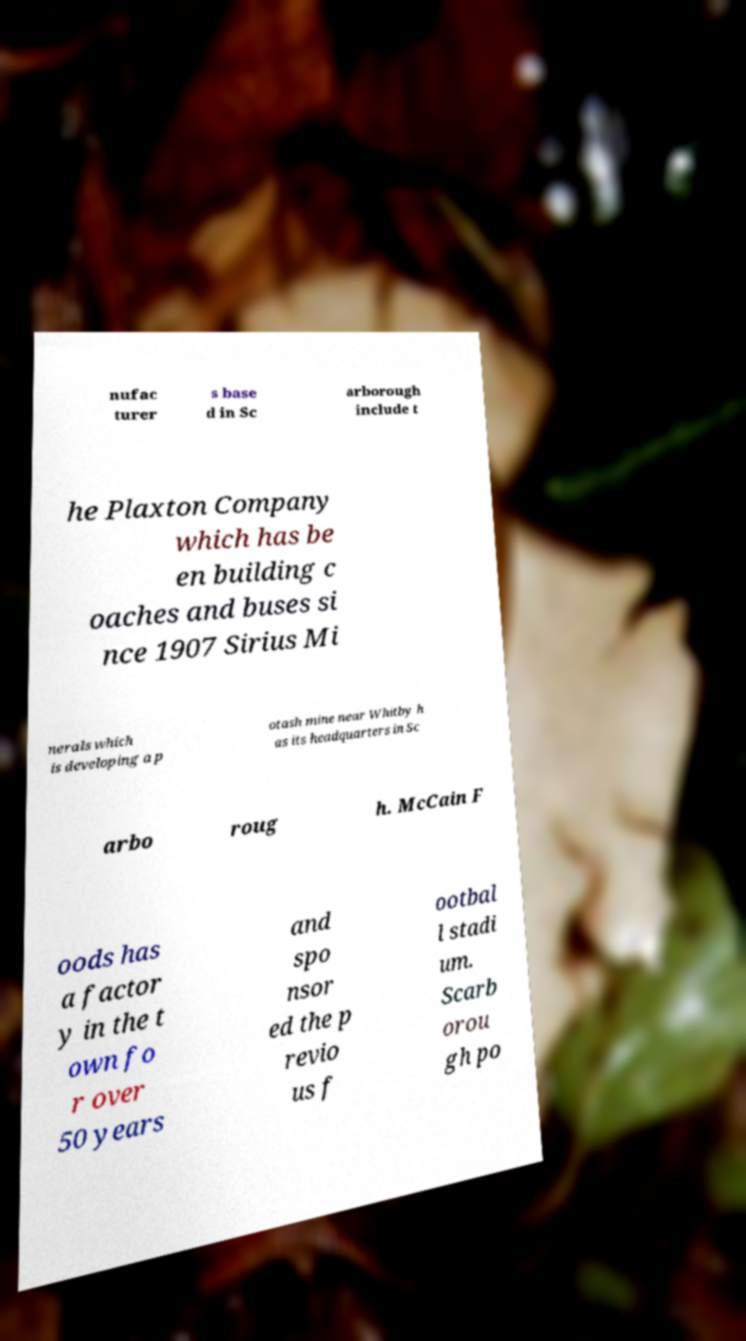What messages or text are displayed in this image? I need them in a readable, typed format. nufac turer s base d in Sc arborough include t he Plaxton Company which has be en building c oaches and buses si nce 1907 Sirius Mi nerals which is developing a p otash mine near Whitby h as its headquarters in Sc arbo roug h. McCain F oods has a factor y in the t own fo r over 50 years and spo nsor ed the p revio us f ootbal l stadi um. Scarb orou gh po 